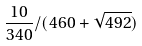Convert formula to latex. <formula><loc_0><loc_0><loc_500><loc_500>\frac { 1 0 } { 3 4 0 } / ( 4 6 0 + \sqrt { 4 9 2 } )</formula> 